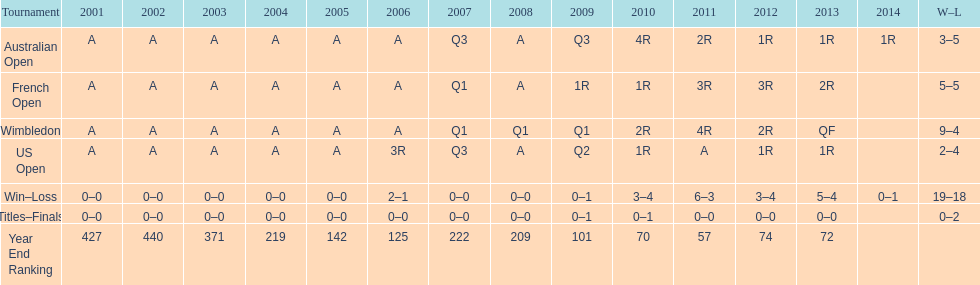What was this players average ranking between 2001 and 2006? 287. I'm looking to parse the entire table for insights. Could you assist me with that? {'header': ['Tournament', '2001', '2002', '2003', '2004', '2005', '2006', '2007', '2008', '2009', '2010', '2011', '2012', '2013', '2014', 'W–L'], 'rows': [['Australian Open', 'A', 'A', 'A', 'A', 'A', 'A', 'Q3', 'A', 'Q3', '4R', '2R', '1R', '1R', '1R', '3–5'], ['French Open', 'A', 'A', 'A', 'A', 'A', 'A', 'Q1', 'A', '1R', '1R', '3R', '3R', '2R', '', '5–5'], ['Wimbledon', 'A', 'A', 'A', 'A', 'A', 'A', 'Q1', 'Q1', 'Q1', '2R', '4R', '2R', 'QF', '', '9–4'], ['US Open', 'A', 'A', 'A', 'A', 'A', '3R', 'Q3', 'A', 'Q2', '1R', 'A', '1R', '1R', '', '2–4'], ['Win–Loss', '0–0', '0–0', '0–0', '0–0', '0–0', '2–1', '0–0', '0–0', '0–1', '3–4', '6–3', '3–4', '5–4', '0–1', '19–18'], ['Titles–Finals', '0–0', '0–0', '0–0', '0–0', '0–0', '0–0', '0–0', '0–0', '0–1', '0–1', '0–0', '0–0', '0–0', '', '0–2'], ['Year End Ranking', '427', '440', '371', '219', '142', '125', '222', '209', '101', '70', '57', '74', '72', '', '']]} 